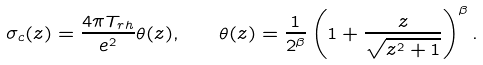Convert formula to latex. <formula><loc_0><loc_0><loc_500><loc_500>\sigma _ { c } ( z ) = \frac { 4 \pi T _ { r h } } { e ^ { 2 } } \theta ( z ) , \quad \theta ( z ) = \frac { 1 } { 2 ^ { \beta } } \left ( 1 + \frac { z } { \sqrt { z ^ { 2 } + 1 } } \right ) ^ { \beta } .</formula> 